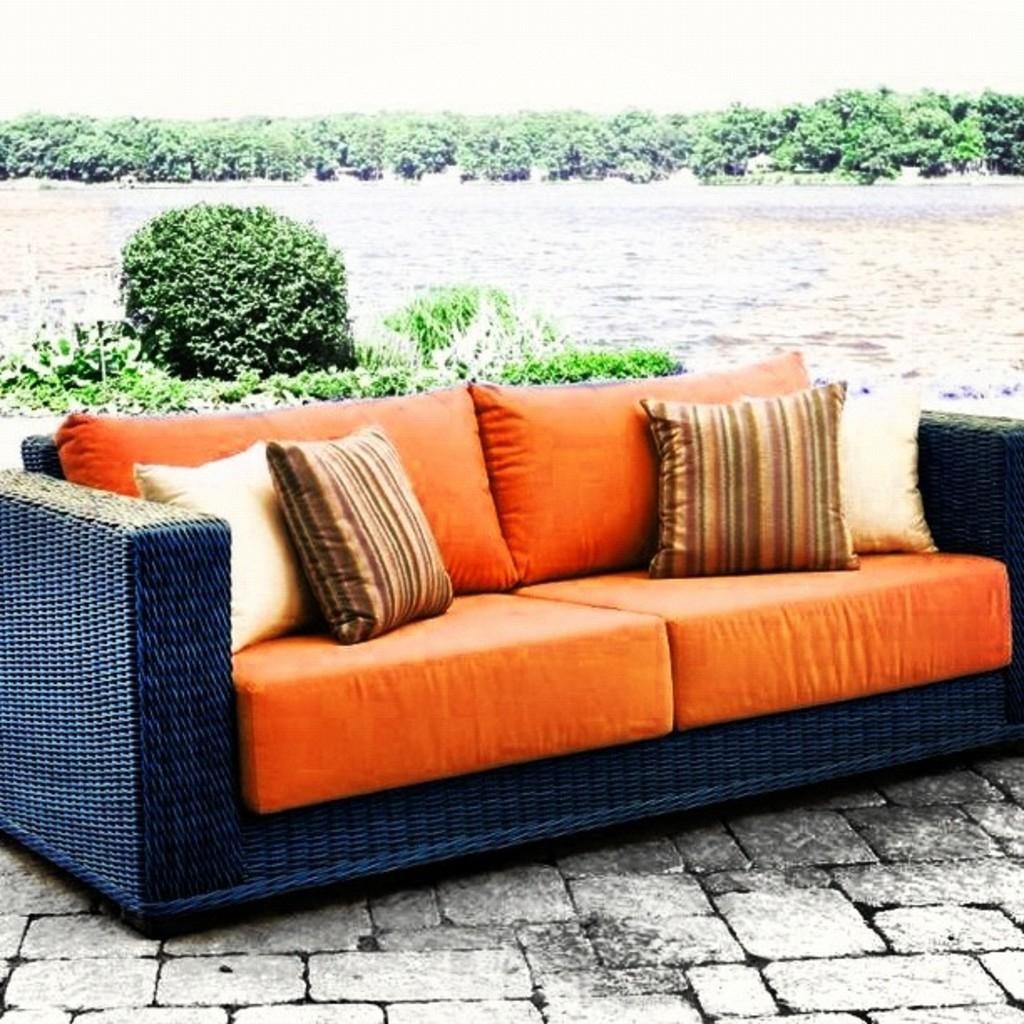What type of furniture is in the image? There is a sofa in the image. What is placed on the sofa? There are pillows on the sofa. Where is the sofa located? The sofa is on the floor. What can be seen in the background of the image? Trees, water, and the sky are visible in the background of the image. What type of cough medicine is on the sofa in the image? There is no cough medicine present in the image; it features a sofa with pillows on it. Who is the servant standing next to the sofa in the image? There is no servant present in the image; it only shows a sofa with pillows on it and the background. 